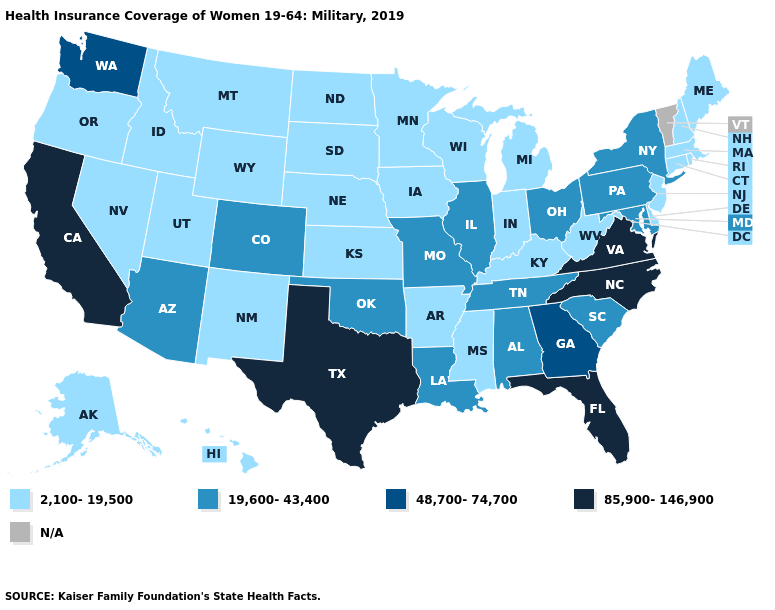Does Illinois have the highest value in the MidWest?
Answer briefly. Yes. What is the lowest value in the USA?
Short answer required. 2,100-19,500. What is the value of Mississippi?
Give a very brief answer. 2,100-19,500. What is the value of Wyoming?
Quick response, please. 2,100-19,500. What is the value of Utah?
Be succinct. 2,100-19,500. Name the states that have a value in the range 2,100-19,500?
Short answer required. Alaska, Arkansas, Connecticut, Delaware, Hawaii, Idaho, Indiana, Iowa, Kansas, Kentucky, Maine, Massachusetts, Michigan, Minnesota, Mississippi, Montana, Nebraska, Nevada, New Hampshire, New Jersey, New Mexico, North Dakota, Oregon, Rhode Island, South Dakota, Utah, West Virginia, Wisconsin, Wyoming. What is the highest value in the USA?
Be succinct. 85,900-146,900. What is the highest value in states that border Rhode Island?
Short answer required. 2,100-19,500. What is the value of Idaho?
Write a very short answer. 2,100-19,500. Which states have the lowest value in the USA?
Be succinct. Alaska, Arkansas, Connecticut, Delaware, Hawaii, Idaho, Indiana, Iowa, Kansas, Kentucky, Maine, Massachusetts, Michigan, Minnesota, Mississippi, Montana, Nebraska, Nevada, New Hampshire, New Jersey, New Mexico, North Dakota, Oregon, Rhode Island, South Dakota, Utah, West Virginia, Wisconsin, Wyoming. Name the states that have a value in the range 2,100-19,500?
Give a very brief answer. Alaska, Arkansas, Connecticut, Delaware, Hawaii, Idaho, Indiana, Iowa, Kansas, Kentucky, Maine, Massachusetts, Michigan, Minnesota, Mississippi, Montana, Nebraska, Nevada, New Hampshire, New Jersey, New Mexico, North Dakota, Oregon, Rhode Island, South Dakota, Utah, West Virginia, Wisconsin, Wyoming. Name the states that have a value in the range 48,700-74,700?
Answer briefly. Georgia, Washington. Name the states that have a value in the range 2,100-19,500?
Quick response, please. Alaska, Arkansas, Connecticut, Delaware, Hawaii, Idaho, Indiana, Iowa, Kansas, Kentucky, Maine, Massachusetts, Michigan, Minnesota, Mississippi, Montana, Nebraska, Nevada, New Hampshire, New Jersey, New Mexico, North Dakota, Oregon, Rhode Island, South Dakota, Utah, West Virginia, Wisconsin, Wyoming. What is the value of Texas?
Write a very short answer. 85,900-146,900. Does Maryland have the lowest value in the South?
Keep it brief. No. 